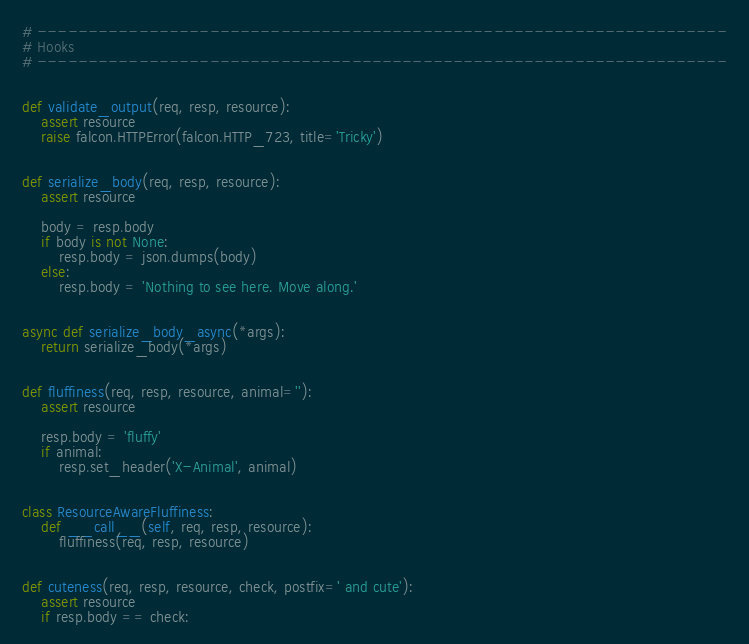<code> <loc_0><loc_0><loc_500><loc_500><_Python_>
# --------------------------------------------------------------------
# Hooks
# --------------------------------------------------------------------


def validate_output(req, resp, resource):
    assert resource
    raise falcon.HTTPError(falcon.HTTP_723, title='Tricky')


def serialize_body(req, resp, resource):
    assert resource

    body = resp.body
    if body is not None:
        resp.body = json.dumps(body)
    else:
        resp.body = 'Nothing to see here. Move along.'


async def serialize_body_async(*args):
    return serialize_body(*args)


def fluffiness(req, resp, resource, animal=''):
    assert resource

    resp.body = 'fluffy'
    if animal:
        resp.set_header('X-Animal', animal)


class ResourceAwareFluffiness:
    def __call__(self, req, resp, resource):
        fluffiness(req, resp, resource)


def cuteness(req, resp, resource, check, postfix=' and cute'):
    assert resource
    if resp.body == check:</code> 